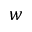<formula> <loc_0><loc_0><loc_500><loc_500>w</formula> 